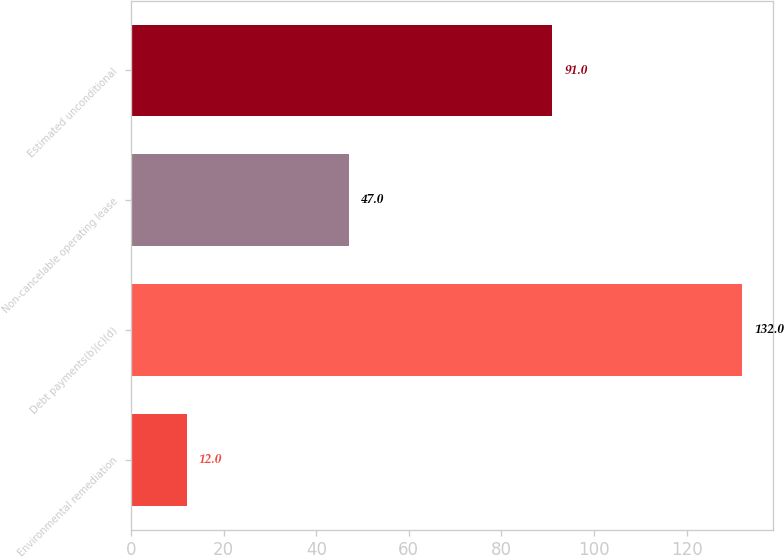<chart> <loc_0><loc_0><loc_500><loc_500><bar_chart><fcel>Environmental remediation<fcel>Debt payments(b)(c)(d)<fcel>Non-cancelable operating lease<fcel>Estimated unconditional<nl><fcel>12<fcel>132<fcel>47<fcel>91<nl></chart> 